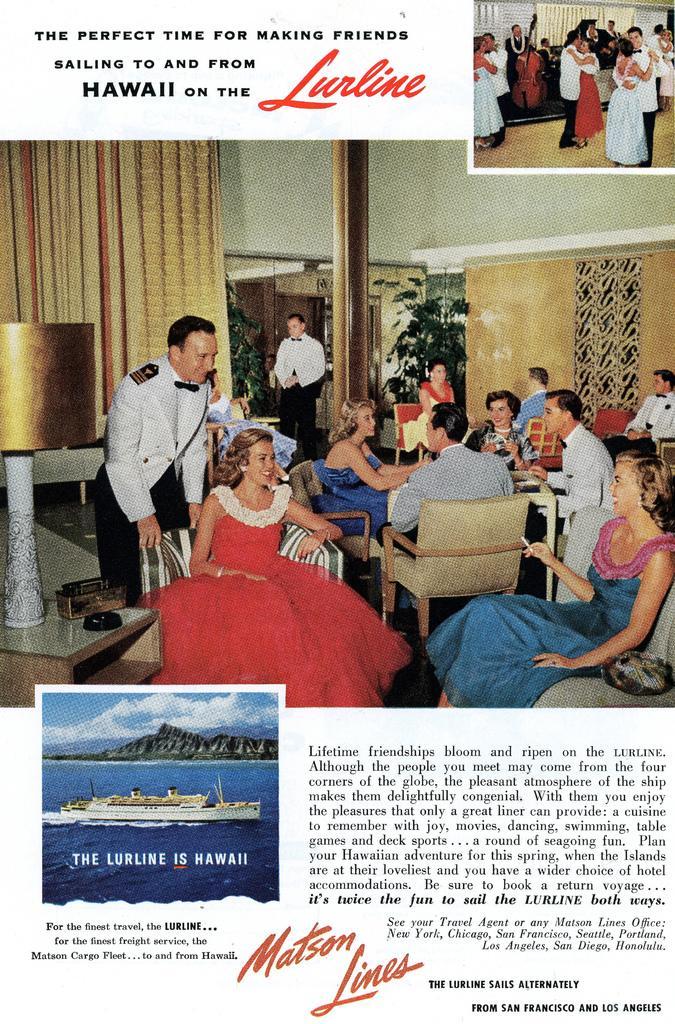Can you describe this image briefly? This image is magazine. In the center of the image we can see some persons, chairs, wall, pole, plants, lamp, floor. At the top of the image we can see some persons, floor, wall, window and some text. At the bottom of the image we can see boat, water, clouds, mountains and some text. 